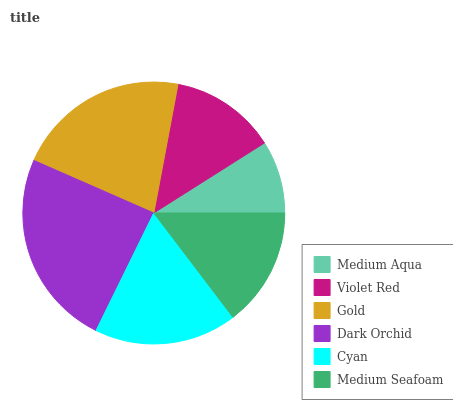Is Medium Aqua the minimum?
Answer yes or no. Yes. Is Dark Orchid the maximum?
Answer yes or no. Yes. Is Violet Red the minimum?
Answer yes or no. No. Is Violet Red the maximum?
Answer yes or no. No. Is Violet Red greater than Medium Aqua?
Answer yes or no. Yes. Is Medium Aqua less than Violet Red?
Answer yes or no. Yes. Is Medium Aqua greater than Violet Red?
Answer yes or no. No. Is Violet Red less than Medium Aqua?
Answer yes or no. No. Is Cyan the high median?
Answer yes or no. Yes. Is Medium Seafoam the low median?
Answer yes or no. Yes. Is Gold the high median?
Answer yes or no. No. Is Cyan the low median?
Answer yes or no. No. 